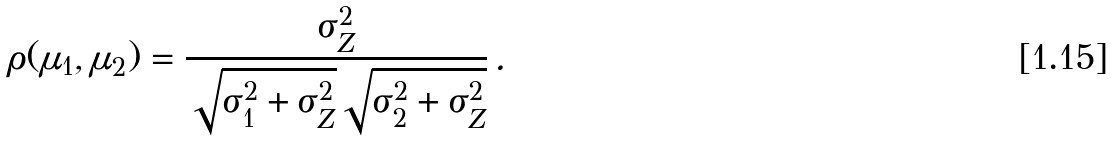Convert formula to latex. <formula><loc_0><loc_0><loc_500><loc_500>\rho ( \mu _ { 1 } , \mu _ { 2 } ) = \frac { \sigma _ { Z } ^ { 2 } } { \sqrt { \sigma _ { 1 } ^ { 2 } + \sigma _ { Z } ^ { 2 } } \sqrt { \sigma _ { 2 } ^ { 2 } + \sigma _ { Z } ^ { 2 } } } \, .</formula> 